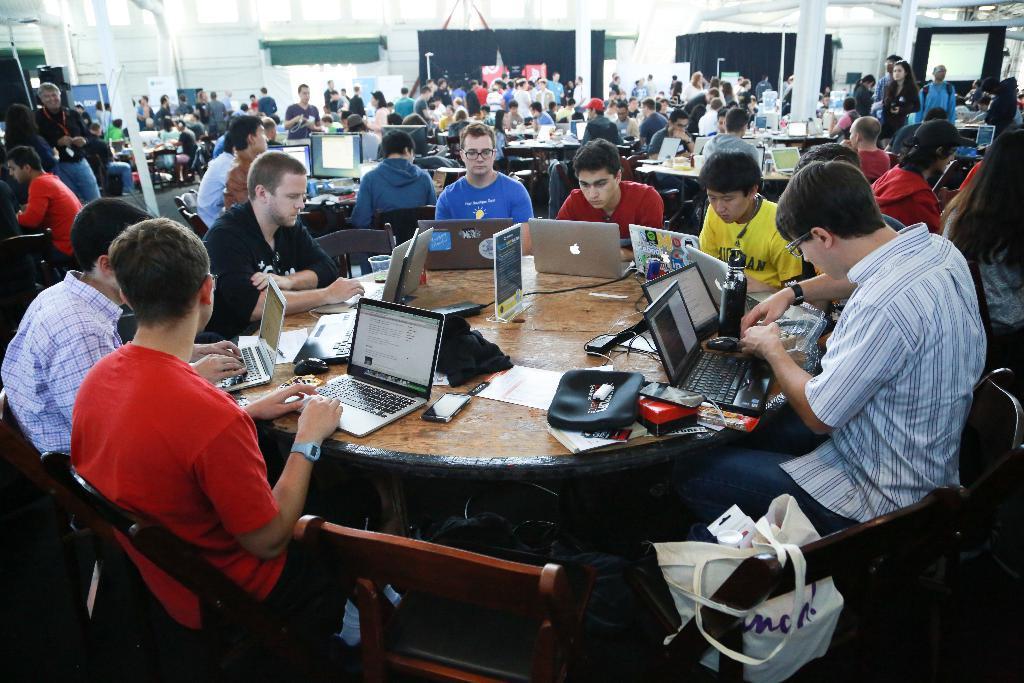Please provide a concise description of this image. In this image we can see the people sitting on the chairs in front of the tables. On the tables we can see the laptop's, mouse, wires and also the text boards. We can also see a bag, poles, windows, curtains and also the display screens. We can also see the people standing. 